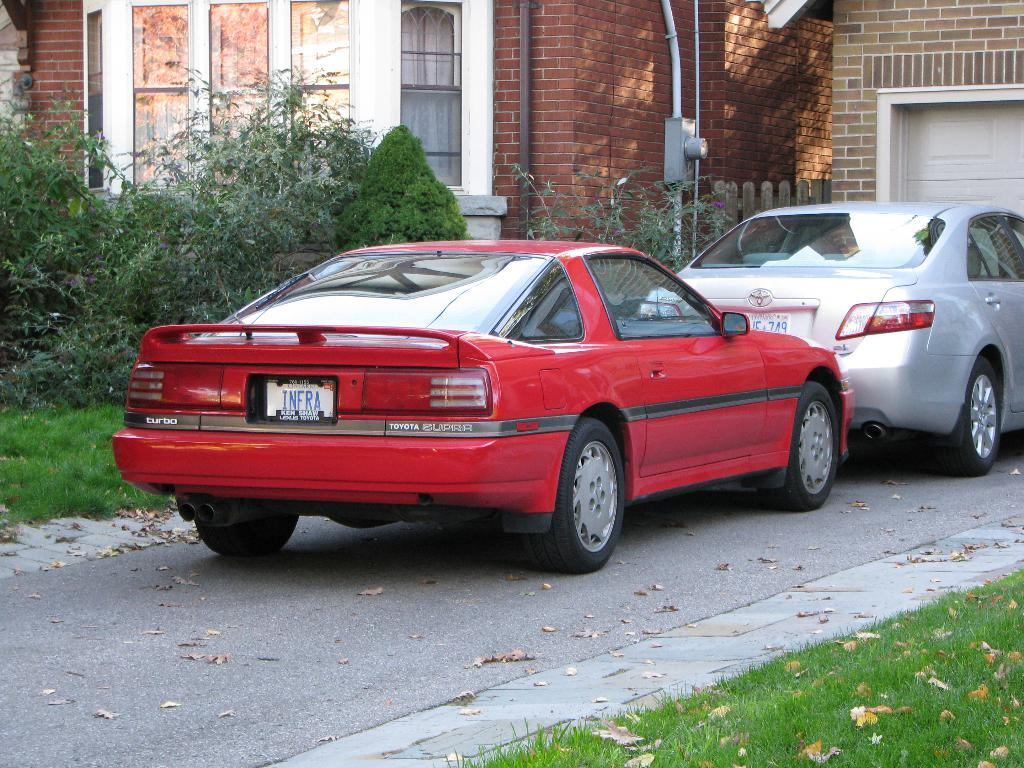How many cars are on the road in the image? There are two cars on the road in the image. What can be seen in the background of the image? There is a building, windows, pipes, plants, grass, and other objects visible in the background. Can you describe the building in the background? The building in the background has visible windows and pipes. What type of vegetation is present in the background? Plants and grass are visible in the background. What type of soup is being served in the image? There is no soup present in the image. Where is the dad in the image? There is no dad present in the image. 